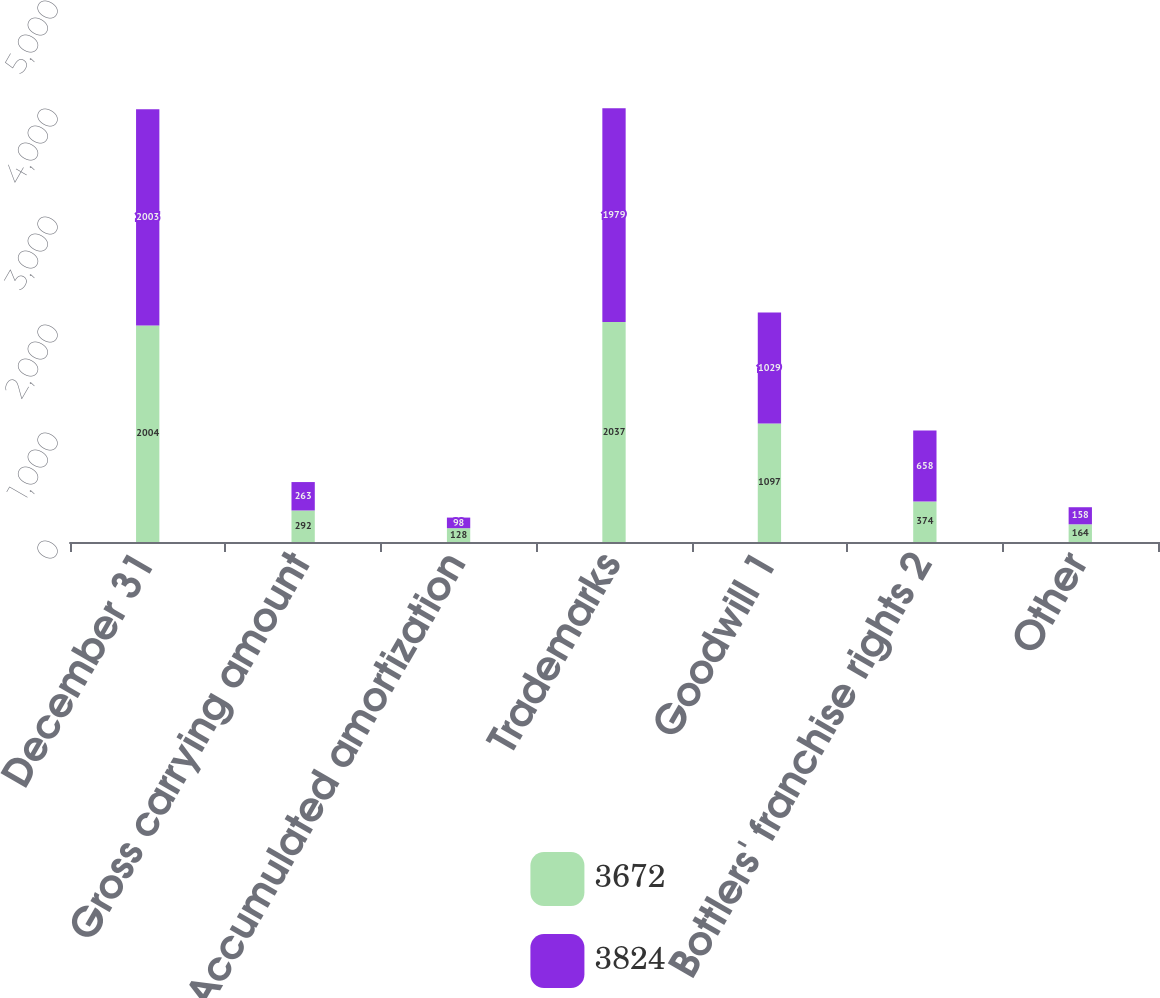Convert chart to OTSL. <chart><loc_0><loc_0><loc_500><loc_500><stacked_bar_chart><ecel><fcel>December 31<fcel>Gross carrying amount<fcel>Accumulated amortization<fcel>Trademarks<fcel>Goodwill 1<fcel>Bottlers' franchise rights 2<fcel>Other<nl><fcel>3672<fcel>2004<fcel>292<fcel>128<fcel>2037<fcel>1097<fcel>374<fcel>164<nl><fcel>3824<fcel>2003<fcel>263<fcel>98<fcel>1979<fcel>1029<fcel>658<fcel>158<nl></chart> 